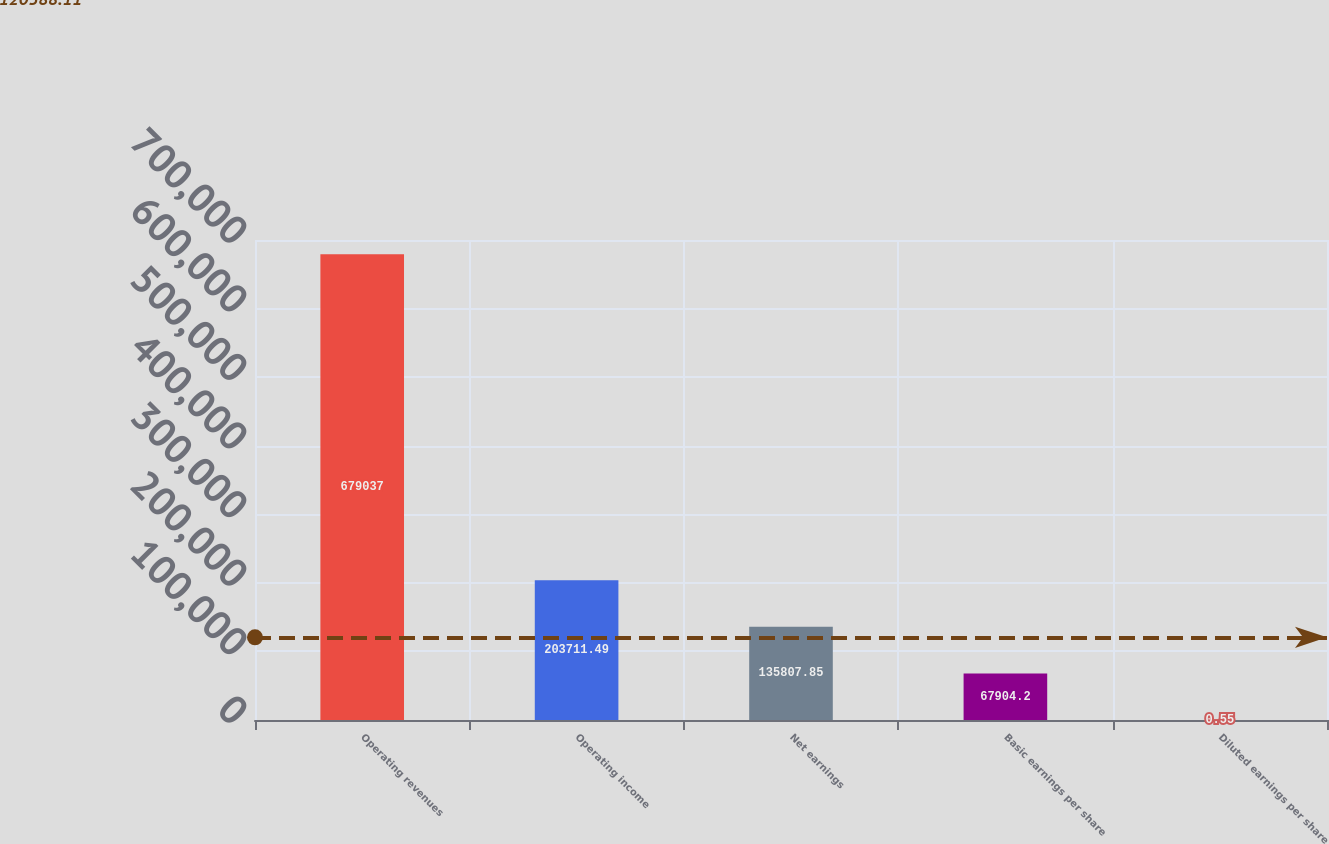Convert chart. <chart><loc_0><loc_0><loc_500><loc_500><bar_chart><fcel>Operating revenues<fcel>Operating income<fcel>Net earnings<fcel>Basic earnings per share<fcel>Diluted earnings per share<nl><fcel>679037<fcel>203711<fcel>135808<fcel>67904.2<fcel>0.55<nl></chart> 